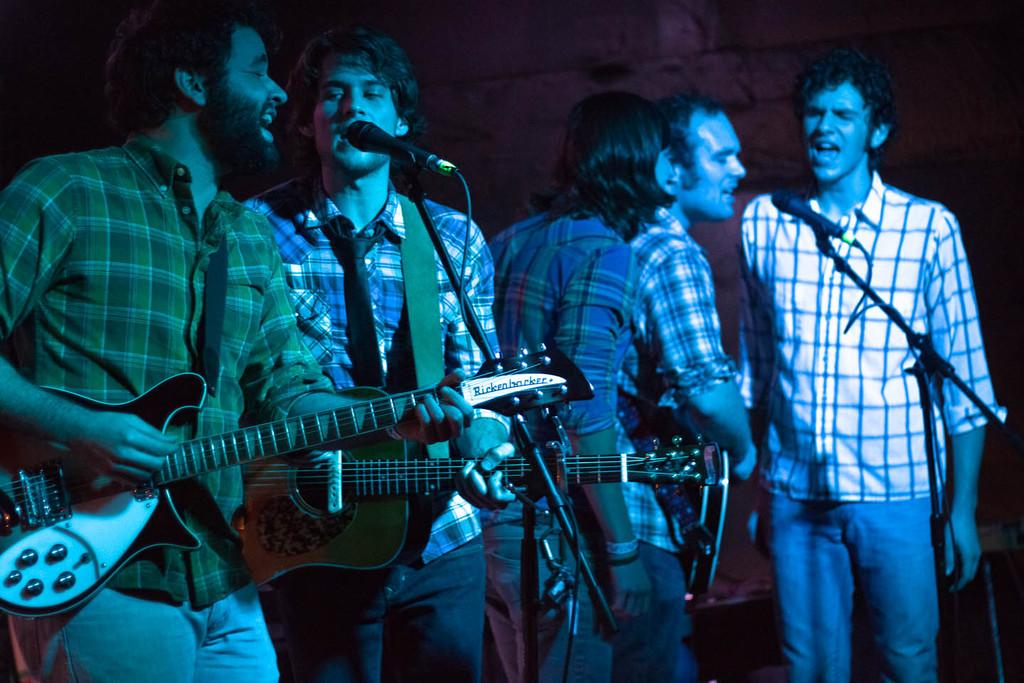How many people are present in the image? There are five people in the image. What are the people doing in the image? The people are standing in front of a microphone. Can you describe the activities of the people on the left side of the image? Two persons are playing guitar on the left side of the image. What type of rail can be seen in the image? There is no rail present in the image. How many boats are visible in the image? There are no boats present in the image. 